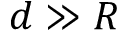<formula> <loc_0><loc_0><loc_500><loc_500>d \gg R</formula> 